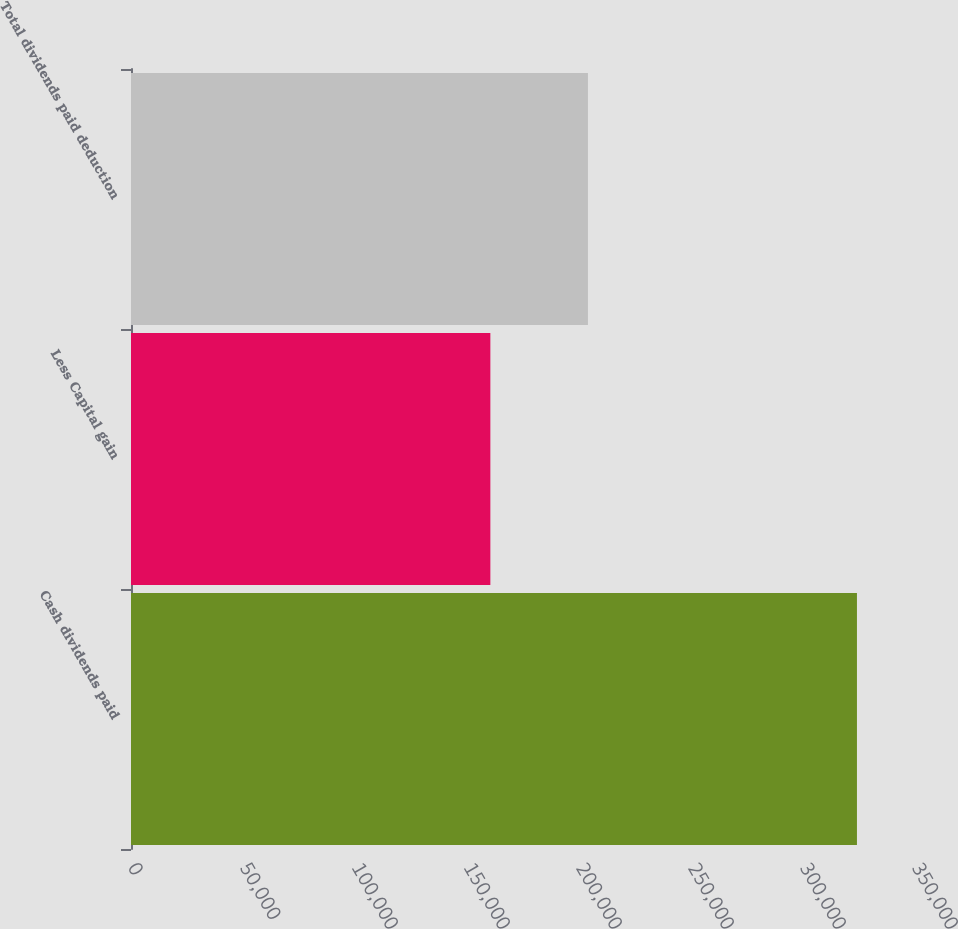Convert chart. <chart><loc_0><loc_0><loc_500><loc_500><bar_chart><fcel>Cash dividends paid<fcel>Less Capital gain<fcel>Total dividends paid deduction<nl><fcel>324085<fcel>160428<fcel>203988<nl></chart> 